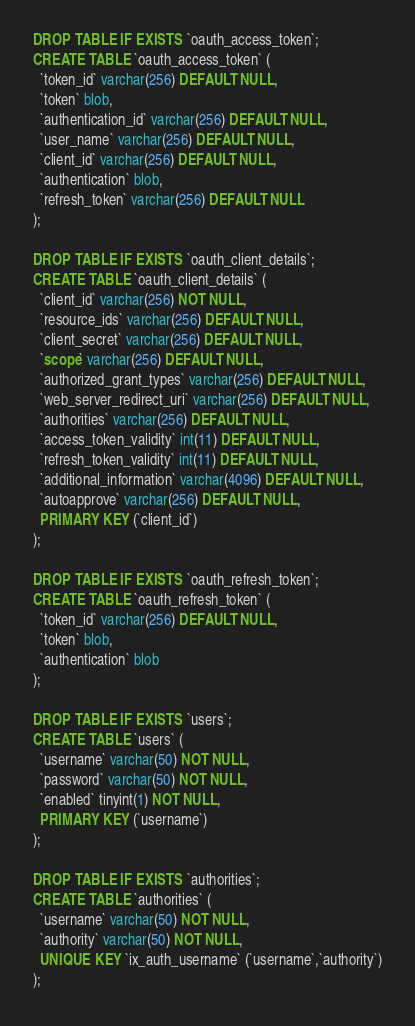<code> <loc_0><loc_0><loc_500><loc_500><_SQL_>DROP TABLE IF EXISTS `oauth_access_token`;
CREATE TABLE `oauth_access_token` (
  `token_id` varchar(256) DEFAULT NULL,
  `token` blob,
  `authentication_id` varchar(256) DEFAULT NULL,
  `user_name` varchar(256) DEFAULT NULL,
  `client_id` varchar(256) DEFAULT NULL,
  `authentication` blob,
  `refresh_token` varchar(256) DEFAULT NULL
);

DROP TABLE IF EXISTS `oauth_client_details`;
CREATE TABLE `oauth_client_details` (
  `client_id` varchar(256) NOT NULL,
  `resource_ids` varchar(256) DEFAULT NULL,
  `client_secret` varchar(256) DEFAULT NULL,
  `scope` varchar(256) DEFAULT NULL,
  `authorized_grant_types` varchar(256) DEFAULT NULL,
  `web_server_redirect_uri` varchar(256) DEFAULT NULL,
  `authorities` varchar(256) DEFAULT NULL,
  `access_token_validity` int(11) DEFAULT NULL,
  `refresh_token_validity` int(11) DEFAULT NULL,
  `additional_information` varchar(4096) DEFAULT NULL,
  `autoapprove` varchar(256) DEFAULT NULL,
  PRIMARY KEY (`client_id`)
);

DROP TABLE IF EXISTS `oauth_refresh_token`;
CREATE TABLE `oauth_refresh_token` (
  `token_id` varchar(256) DEFAULT NULL,
  `token` blob,
  `authentication` blob
);

DROP TABLE IF EXISTS `users`;
CREATE TABLE `users` (
  `username` varchar(50) NOT NULL,
  `password` varchar(50) NOT NULL,
  `enabled` tinyint(1) NOT NULL,
  PRIMARY KEY (`username`)
);

DROP TABLE IF EXISTS `authorities`;
CREATE TABLE `authorities` (
  `username` varchar(50) NOT NULL,
  `authority` varchar(50) NOT NULL,
  UNIQUE KEY `ix_auth_username` (`username`,`authority`)
);</code> 